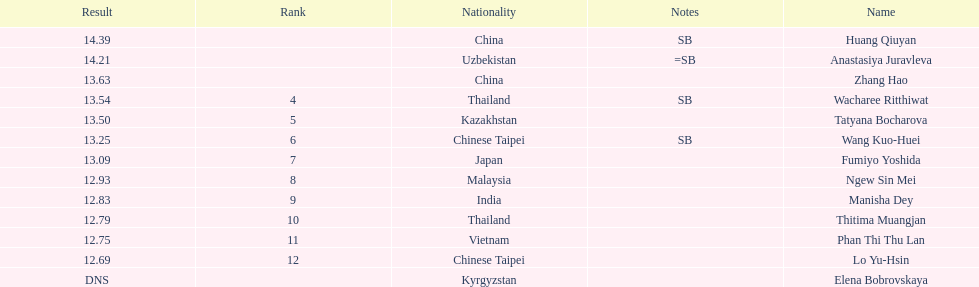Can you give me this table as a dict? {'header': ['Result', 'Rank', 'Nationality', 'Notes', 'Name'], 'rows': [['14.39', '', 'China', 'SB', 'Huang Qiuyan'], ['14.21', '', 'Uzbekistan', '=SB', 'Anastasiya Juravleva'], ['13.63', '', 'China', '', 'Zhang Hao'], ['13.54', '4', 'Thailand', 'SB', 'Wacharee Ritthiwat'], ['13.50', '5', 'Kazakhstan', '', 'Tatyana Bocharova'], ['13.25', '6', 'Chinese Taipei', 'SB', 'Wang Kuo-Huei'], ['13.09', '7', 'Japan', '', 'Fumiyo Yoshida'], ['12.93', '8', 'Malaysia', '', 'Ngew Sin Mei'], ['12.83', '9', 'India', '', 'Manisha Dey'], ['12.79', '10', 'Thailand', '', 'Thitima Muangjan'], ['12.75', '11', 'Vietnam', '', 'Phan Thi Thu Lan'], ['12.69', '12', 'Chinese Taipei', '', 'Lo Yu-Hsin'], ['DNS', '', 'Kyrgyzstan', '', 'Elena Bobrovskaya']]} What is the difference between huang qiuyan's result and fumiyo yoshida's result? 1.3. 